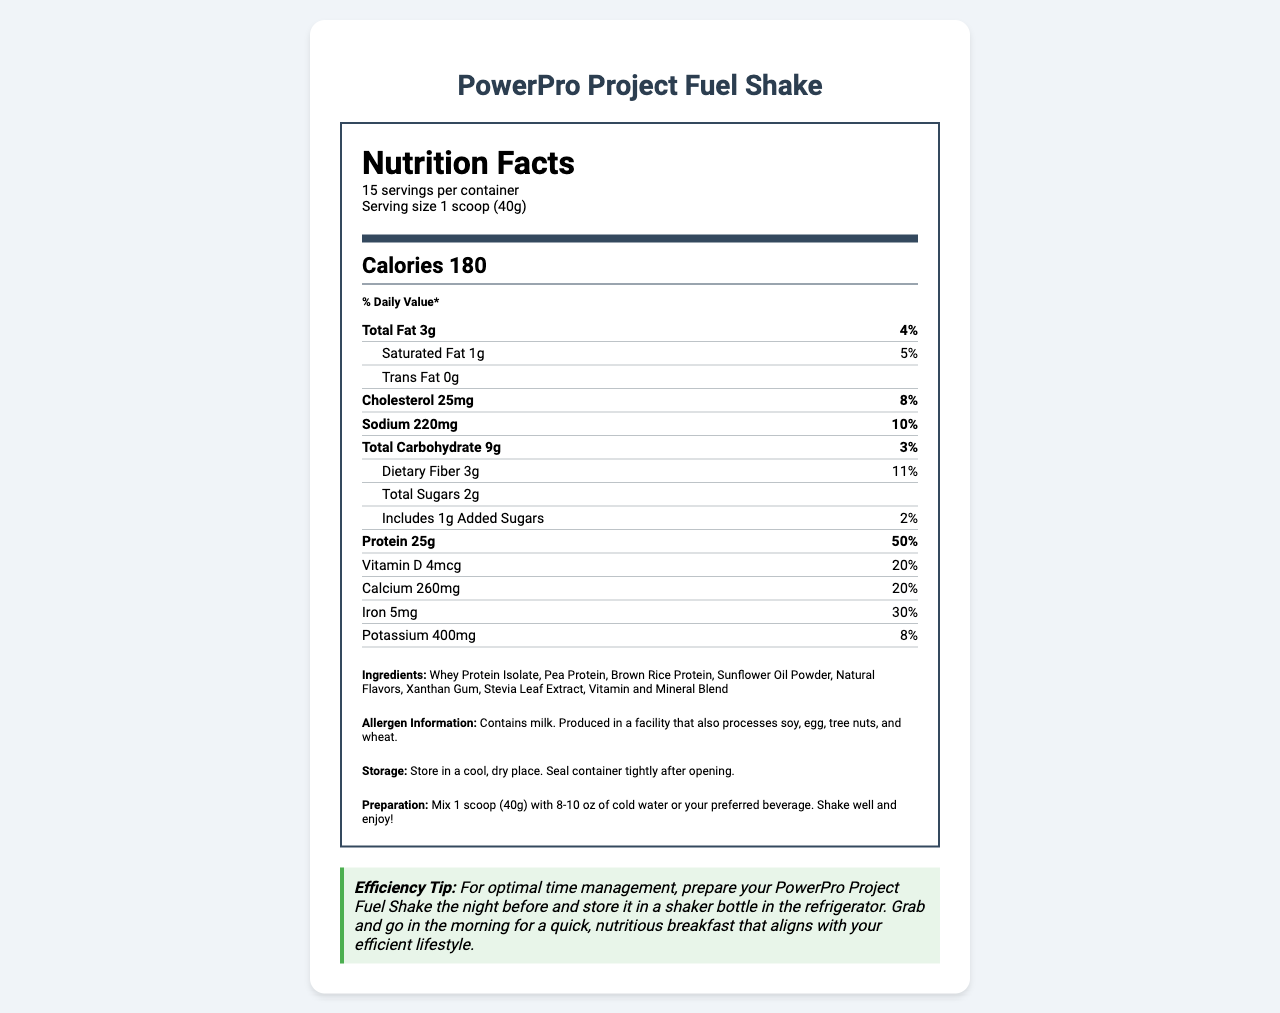What is the serving size of the PowerPro Project Fuel Shake? The serving size is clearly stated as "1 scoop (40g)" in the serving information.
Answer: 1 scoop (40g) How many calories are there per serving of the PowerPro Project Fuel Shake? The calorie information is given as "Calories 180" in the calorie info section.
Answer: 180 Which vitamin in the PowerPro Project Fuel Shake has the highest daily value percentage? A. Vitamin D B. Vitamin A C. Vitamin C D. Vitamin B6 The document indicates that Vitamin A, Vitamin C, Vitamin E, Vitamin K, and many B vitamins have a daily value percentage of 50%, but since Vitamin A is listed first among them, it is presumed to be the answer in this context.
Answer: B. Vitamin A What is the primary protein source in the PowerPro Project Fuel Shake? The ingredients list the proteins, with Whey Protein Isolate appearing first.
Answer: Whey Protein Isolate Does the PowerPro Project Fuel Shake contain any trans fat? The trans fat content is listed as 0g, indicating that there is no trans fat.
Answer: No What is the percentage of daily value for dietary fiber in the PowerPro Project Fuel Shake? The document specifies that the daily value for dietary fiber is 11%.
Answer: 11% Which mineral has the highest daily value percentage in one serving of the shake? A. Calcium B. Iron C. Phosphorus D. Magnesium Iron has a daily value percentage of 30%, which is the highest among the listed minerals.
Answer: B. Iron How many grams of total carbohydrates are in each serving of the shake? Each serving contains 9 grams of total carbohydrates as listed in the nutrition facts.
Answer: 9g What are the storage instructions for the PowerPro Project Fuel Shake? The document specifies these storage instructions clearly.
Answer: Store in a cool, dry place. Seal container tightly after opening. Can you determine the price of the PowerPro Project Fuel Shake from this document? The document does not contain any pricing information.
Answer: No 